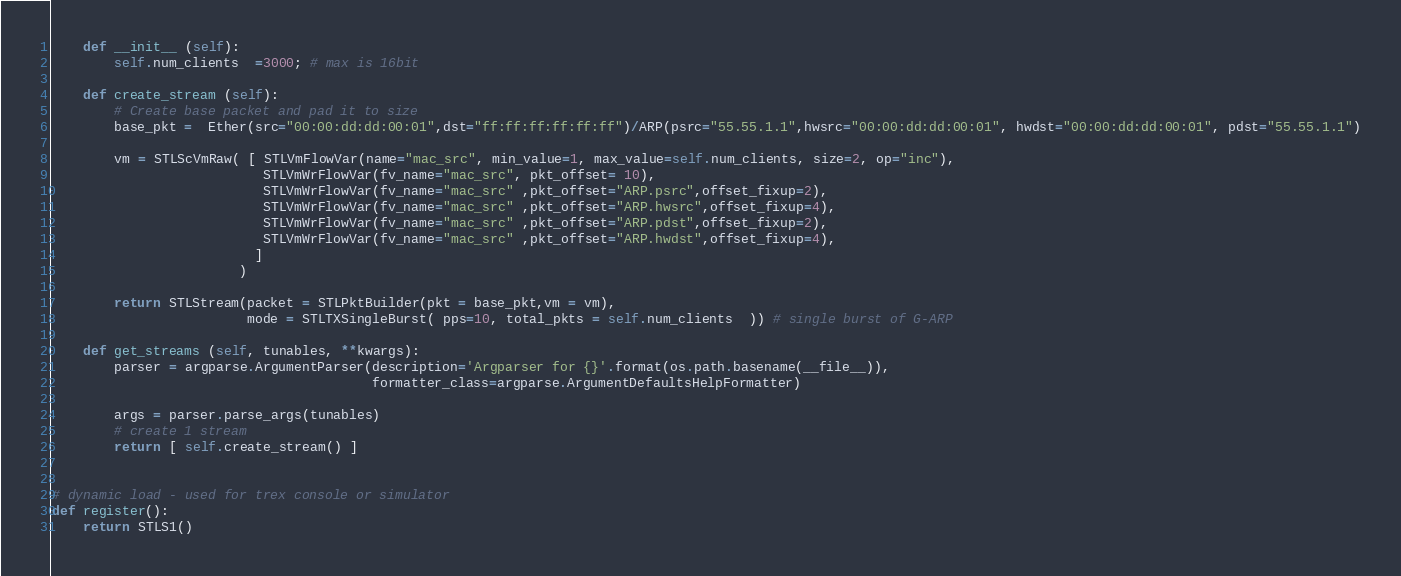<code> <loc_0><loc_0><loc_500><loc_500><_Python_>
    def __init__ (self):
        self.num_clients  =3000; # max is 16bit

    def create_stream (self):
        # Create base packet and pad it to size
        base_pkt =  Ether(src="00:00:dd:dd:00:01",dst="ff:ff:ff:ff:ff:ff")/ARP(psrc="55.55.1.1",hwsrc="00:00:dd:dd:00:01", hwdst="00:00:dd:dd:00:01", pdst="55.55.1.1")

        vm = STLScVmRaw( [ STLVmFlowVar(name="mac_src", min_value=1, max_value=self.num_clients, size=2, op="inc"),
                           STLVmWrFlowVar(fv_name="mac_src", pkt_offset= 10),                                        
                           STLVmWrFlowVar(fv_name="mac_src" ,pkt_offset="ARP.psrc",offset_fixup=2),                
                           STLVmWrFlowVar(fv_name="mac_src" ,pkt_offset="ARP.hwsrc",offset_fixup=4),
                           STLVmWrFlowVar(fv_name="mac_src" ,pkt_offset="ARP.pdst",offset_fixup=2),                
                           STLVmWrFlowVar(fv_name="mac_src" ,pkt_offset="ARP.hwdst",offset_fixup=4),
                          ]
                        )

        return STLStream(packet = STLPktBuilder(pkt = base_pkt,vm = vm),
                         mode = STLTXSingleBurst( pps=10, total_pkts = self.num_clients  )) # single burst of G-ARP

    def get_streams (self, tunables, **kwargs):
        parser = argparse.ArgumentParser(description='Argparser for {}'.format(os.path.basename(__file__)), 
                                         formatter_class=argparse.ArgumentDefaultsHelpFormatter)

        args = parser.parse_args(tunables)
        # create 1 stream 
        return [ self.create_stream() ]


# dynamic load - used for trex console or simulator
def register():
    return STLS1()



</code> 